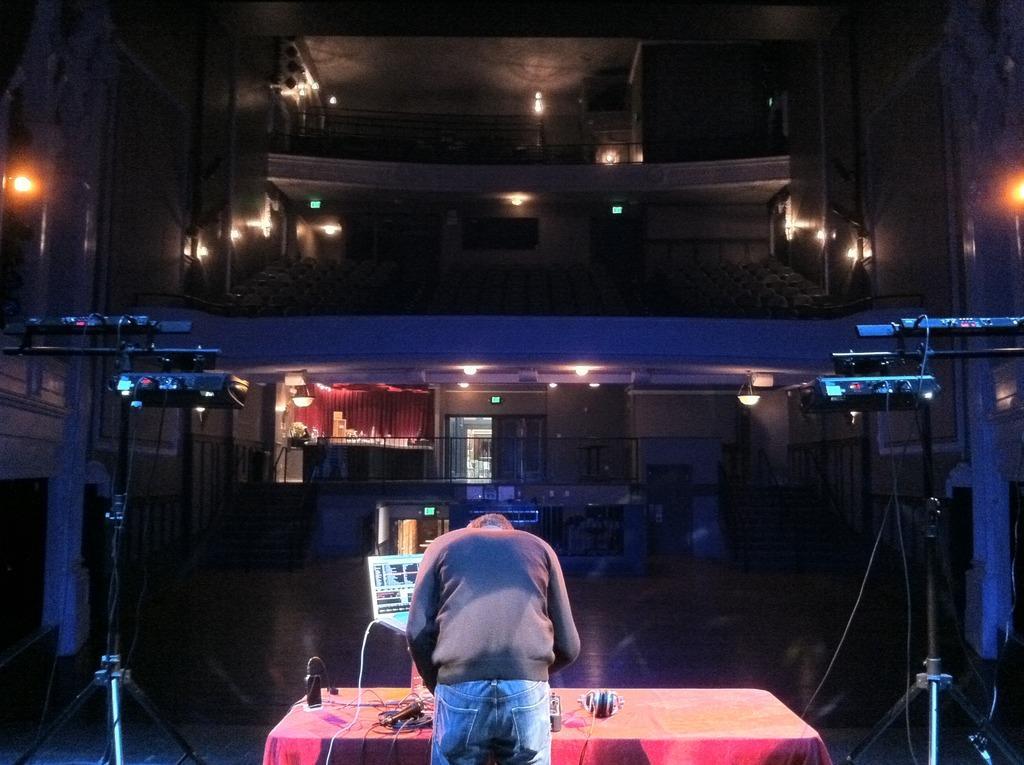Describe this image in one or two sentences. In this image we can see a person standing in front of a table on which a headset microphone and a mobile and a laptop are kept on it. In the background we can see different lights ,staircase and curtain. 